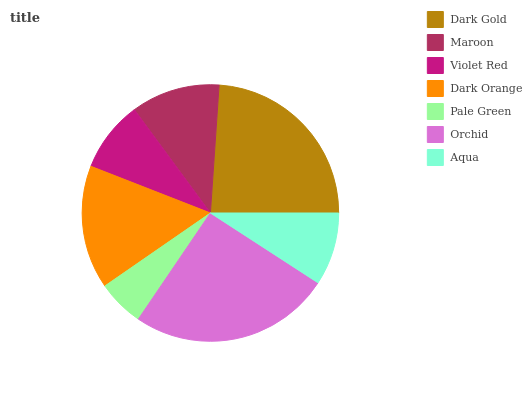Is Pale Green the minimum?
Answer yes or no. Yes. Is Orchid the maximum?
Answer yes or no. Yes. Is Maroon the minimum?
Answer yes or no. No. Is Maroon the maximum?
Answer yes or no. No. Is Dark Gold greater than Maroon?
Answer yes or no. Yes. Is Maroon less than Dark Gold?
Answer yes or no. Yes. Is Maroon greater than Dark Gold?
Answer yes or no. No. Is Dark Gold less than Maroon?
Answer yes or no. No. Is Maroon the high median?
Answer yes or no. Yes. Is Maroon the low median?
Answer yes or no. Yes. Is Violet Red the high median?
Answer yes or no. No. Is Pale Green the low median?
Answer yes or no. No. 